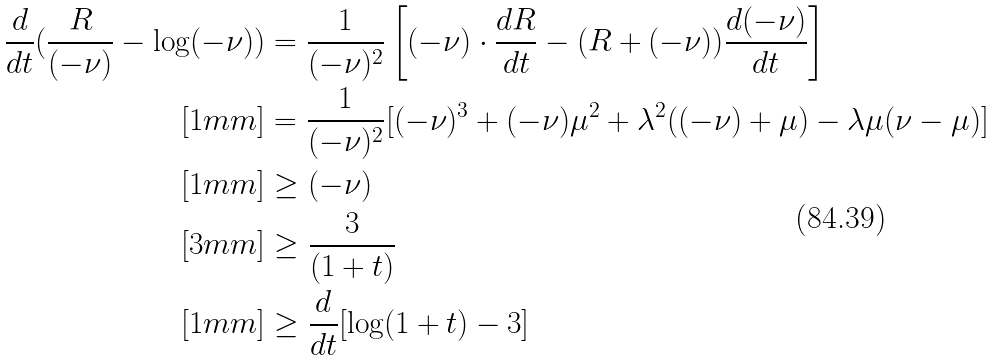Convert formula to latex. <formula><loc_0><loc_0><loc_500><loc_500>\frac { d } { d t } ( \frac { R } { ( - \nu ) } - \log ( - \nu ) ) & = \frac { 1 } { ( - \nu ) ^ { 2 } } \left [ ( - \nu ) \cdot \frac { d R } { d t } - ( R + ( - \nu ) ) \frac { d ( - \nu ) } { d t } \right ] \\ [ 1 m m ] & = \frac { 1 } { ( - \nu ) ^ { 2 } } [ ( - \nu ) ^ { 3 } + ( - \nu ) \mu ^ { 2 } + \lambda ^ { 2 } ( ( - \nu ) + \mu ) - \lambda \mu ( \nu - \mu ) ] \\ [ 1 m m ] & \geq ( - \nu ) \\ [ 3 m m ] & \geq \frac { 3 } { ( 1 + t ) } \\ [ 1 m m ] & \geq \frac { d } { d t } [ \log ( 1 + t ) - 3 ]</formula> 